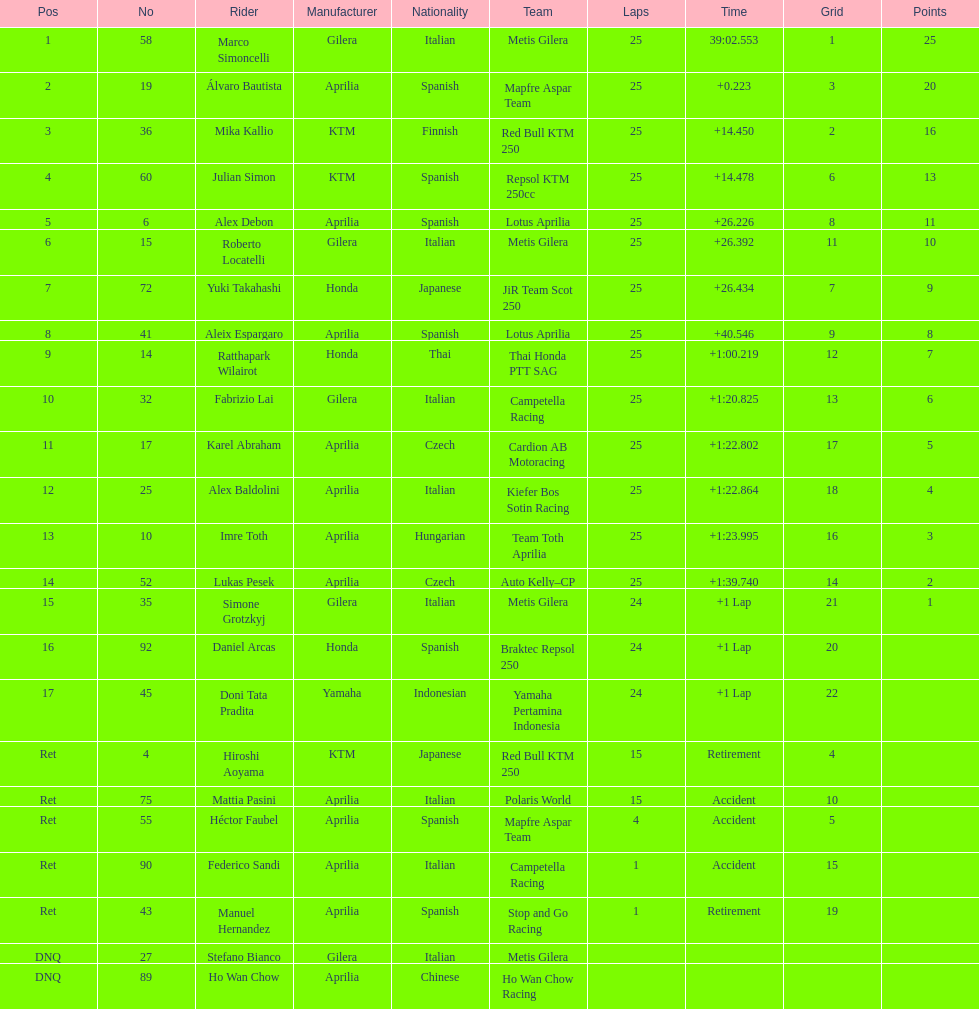The country with the most riders was Italy. 